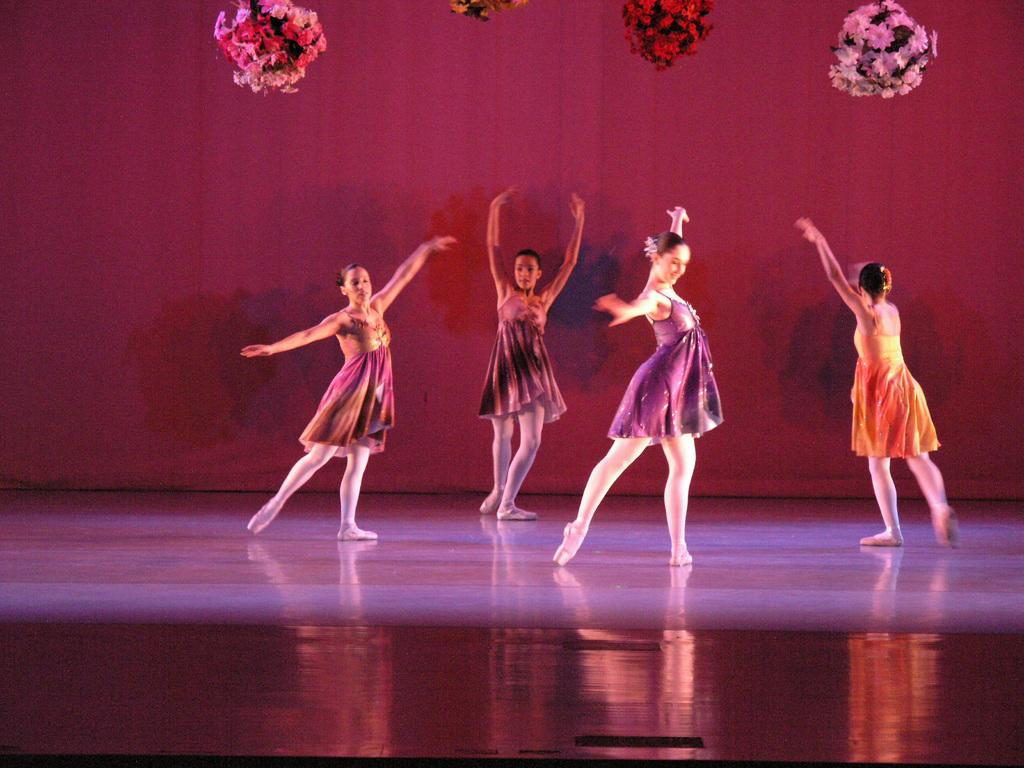How many people are in the image? There are four ladies in the image. What are the ladies doing in the image? The ladies are dancing on the floor. What can be seen in the image besides the ladies? There are flowers visible in the image. What is in the background of the image? There is a curtain in the background of the image. Where is the playground located in the image? There is no playground present in the image. What type of iron is being used by the ladies in the image? There is no iron visible in the image, and the ladies are dancing, not using any iron. 